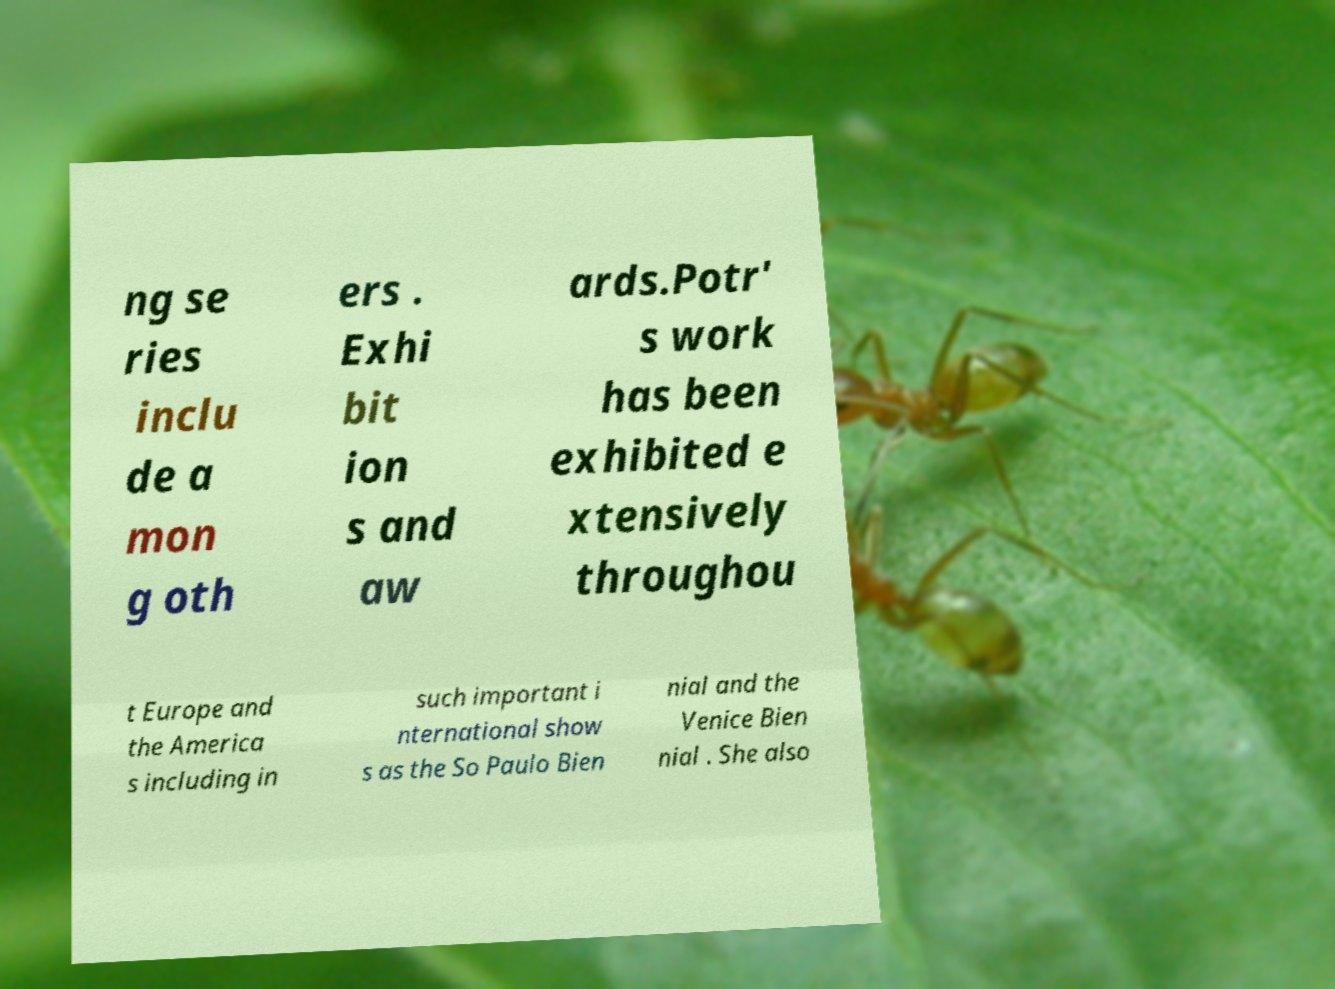There's text embedded in this image that I need extracted. Can you transcribe it verbatim? ng se ries inclu de a mon g oth ers . Exhi bit ion s and aw ards.Potr' s work has been exhibited e xtensively throughou t Europe and the America s including in such important i nternational show s as the So Paulo Bien nial and the Venice Bien nial . She also 